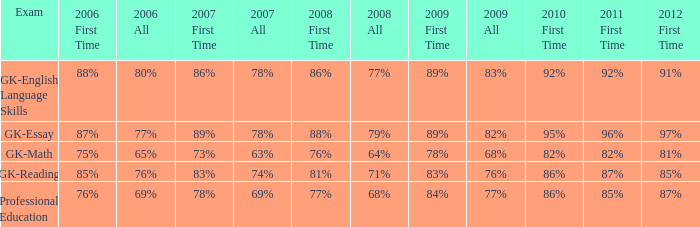What is the percentage for all 2008 when all in 2007 is 69%? 68%. 